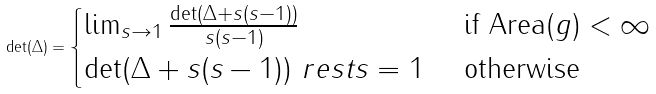<formula> <loc_0><loc_0><loc_500><loc_500>\det ( \Delta ) = \begin{cases} \lim _ { s \to 1 } \frac { \det ( \Delta + s ( s - 1 ) ) } { s ( s - 1 ) } & \text { if Area} ( g ) < \infty \\ \det ( \Delta + s ( s - 1 ) ) \ r e s t { s = 1 } & \text { otherwise } \end{cases}</formula> 